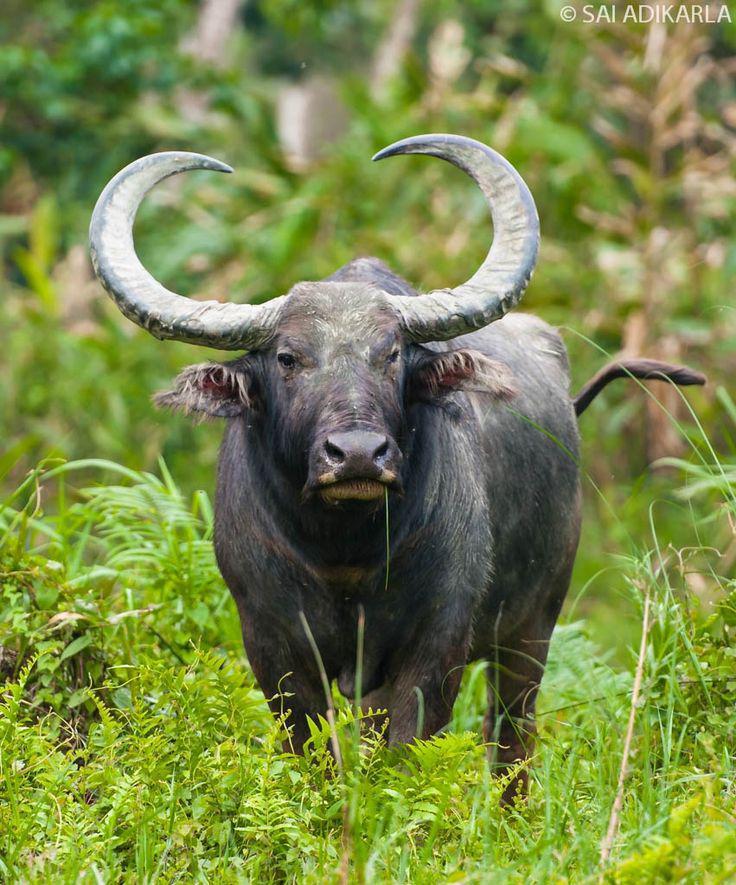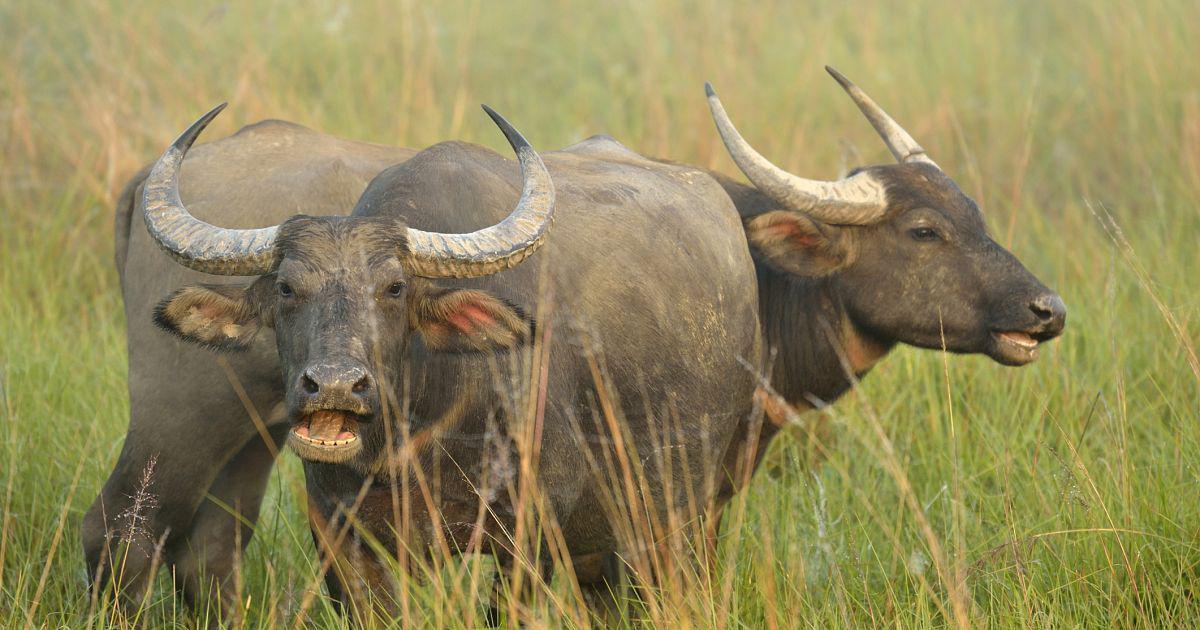The first image is the image on the left, the second image is the image on the right. For the images shown, is this caption "One animal stands in the grass in the image on the left." true? Answer yes or no. Yes. The first image is the image on the left, the second image is the image on the right. Assess this claim about the two images: "The left image contains more water buffalos than the right image.". Correct or not? Answer yes or no. No. 